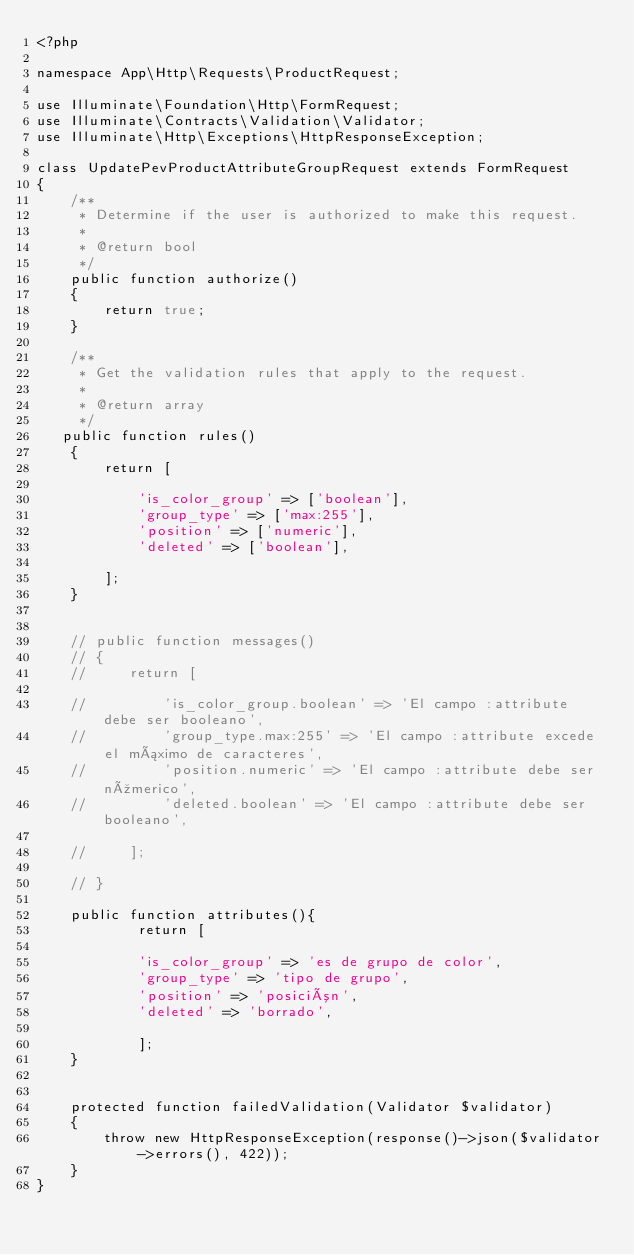<code> <loc_0><loc_0><loc_500><loc_500><_PHP_><?php

namespace App\Http\Requests\ProductRequest;

use Illuminate\Foundation\Http\FormRequest;
use Illuminate\Contracts\Validation\Validator;
use Illuminate\Http\Exceptions\HttpResponseException;

class UpdatePevProductAttributeGroupRequest extends FormRequest
{
    /**
     * Determine if the user is authorized to make this request.
     *
     * @return bool
     */
    public function authorize()
    {
        return true;
    }

    /**
     * Get the validation rules that apply to the request.
     *
     * @return array
     */
   public function rules()
    {
        return [

            'is_color_group' => ['boolean'],
            'group_type' => ['max:255'],
            'position' => ['numeric'],
            'deleted' => ['boolean'],

        ];
    }


    // public function messages()
    // {
    //     return [

    //         'is_color_group.boolean' => 'El campo :attribute debe ser booleano',
    //         'group_type.max:255' => 'El campo :attribute excede el máximo de caracteres',
    //         'position.numeric' => 'El campo :attribute debe ser númerico',
    //         'deleted.boolean' => 'El campo :attribute debe ser booleano',

    //     ];

    // }

    public function attributes(){
            return [

            'is_color_group' => 'es de grupo de color',
            'group_type' => 'tipo de grupo',
            'position' => 'posición',
            'deleted' => 'borrado',

            ];
    }


    protected function failedValidation(Validator $validator)
    {
        throw new HttpResponseException(response()->json($validator->errors(), 422));
    }
}
</code> 